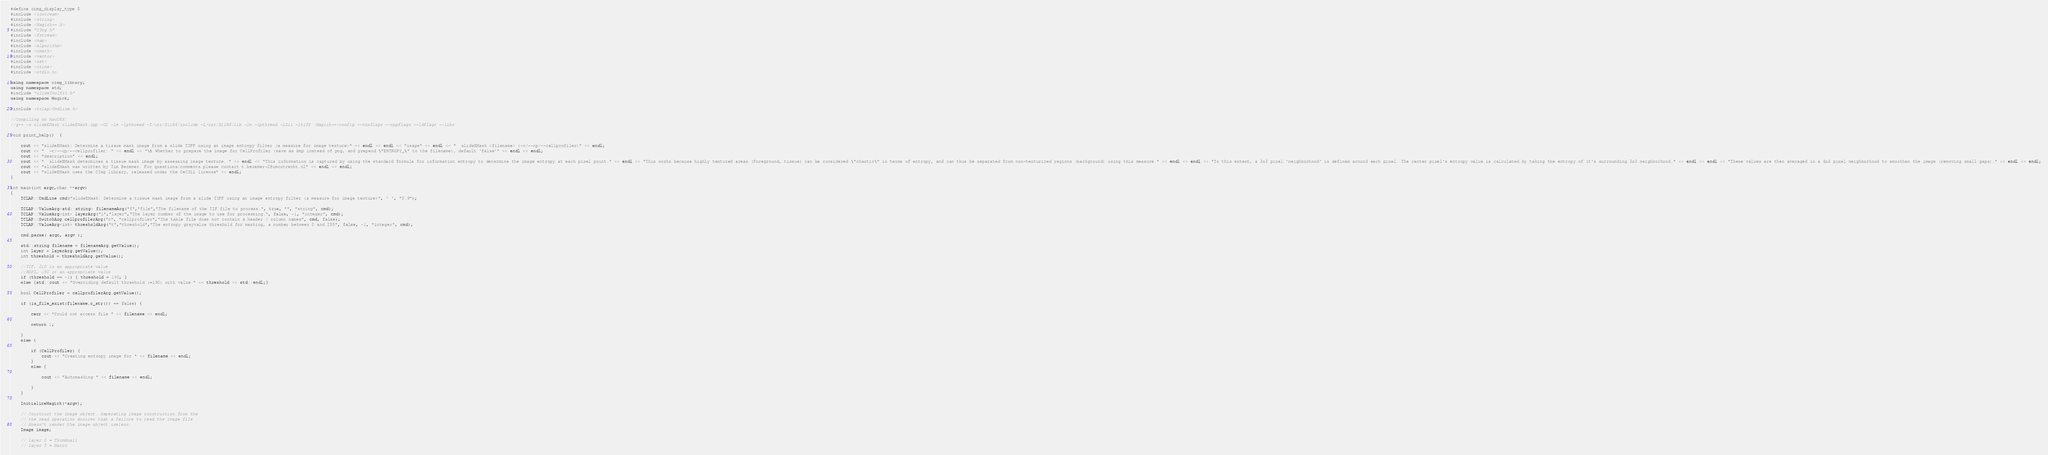<code> <loc_0><loc_0><loc_500><loc_500><_C++_>#define cimg_display_type 0
#include <iostream> 
#include <string>
#include <Magick++.h>
#include "CImg.h"
#include <fstream>
#include <map>
#include <algorithm>
#include <cmath>
#include <vector>
#include <set>
#include <ctime>
#include <stdio.h>

using namespace cimg_library;
using namespace std;
#include "slideToolKit.h"
using namespace Magick;

#include <tclap/CmdLine.h>

//Compiling on MacOSX:
//g++ -o slideEMask slideEMask.cpp -O2 -lm -lpthread -I/usr/X11R6/include -L/usr/X11R6/lib -lm -lpthread -lX11 -ltiff `Magick++-config --cxxflags --cppflags --ldflags --libs`

void print_help()  {

	cout << "slideEMask: Determine a tissue mask image from a slide TIFF using an image entropy filter (a measure for image texture)" << endl << endl << "usage" << endl << "  slideEMask <filename> (-c/--cp/--cellprofiler)" << endl;
	cout << "  -c/--cp/--cellprofiler: " << endl << "\t Whether to prepare the image for CellProfiler (save as bmp instead of png, and prepend \"ENTROPY_\" to the filename), default 'false'" << endl << endl;
	cout << "description" << endl;
	cout << "  slideEMask determines a tissue mask image by assessing image texture. " << endl << "This information is captured by using the standard formula for information entropy to determine the image entropy at each pixel point." << endl << "This works because highly textured areas (foreground, tissue) can be considered \"chaotic\" in terms of entropy, and can thus be separated from non-texturized regions (background) using this measure." << endl << endl << "To this extent, a 3x3 pixel 'neighborhood' is defined around each pixel. The center pixel's entropy value is calculated by taking the entropy of it's surrounding 3x3 neighborhood." << endl << endl << "These values are then averaged in a 4x4 pixel neighborhood to smoothen the image (removing small gaps)." << endl << endl;
	cout << "slideEMask was written by Tim Bezemer. For questions/comments please contact t.bezemer-2@umcutrecht.nl" << endl << endl;
	cout << "slideEMask uses the CImg library, released under the CeCILL license" << endl;
}

int main(int argc,char **argv) 
{ 
	TCLAP::CmdLine cmd("slideEMask: Determine a tissue mask image from a slide TIFF using an image entropy filter (a measure for image texture)", ' ', "0.9");

	TCLAP::ValueArg<std::string> filenameArg("f","file","The filename of the TIF file to process.", true, "", "string", cmd);
	TCLAP::ValueArg<int> layerArg("l","layer","The layer number of the image to use for processing.", false, -1, "integer", cmd);
	TCLAP::SwitchArg cellprofilerArg("c", "cellprofiler","The table file does not contain a header / column names", cmd, false);
	TCLAP::ValueArg<int> thresholdArg("t","threshold","The entropy grayvalue threshold for masking, a number between 0 and 255", false, -1, "integer", cmd);

	cmd.parse( argc, argv );

	std::string filename = filenameArg.getValue();
	int layer = layerArg.getValue();
	int threshold = thresholdArg.getValue();

	//TIF, 210 is an appropriate value
	//NDPI, 190 is an appropriate value
	if (threshold == -1) { threshold = 190; }
	else {std::cout << "Overriding default threshold (=190) with value " << threshold << std::endl;}

	bool CellProfiler = cellprofilerArg.getValue();

	if (is_file_exist(filename.c_str()) == false) {

		cerr << "Could not access file " << filename << endl;

        return 1;

	}
	else {

		if (CellProfiler) {
			cout << "Creating entropy image for " << filename << endl;
		}
		else {

			cout << "Automasking " << filename << endl;

		}
	}

	InitializeMagick(*argv);

    // Construct the image object. Seperating image construction from the 
    // the read operation ensures that a failure to read the image file 
    // doesn't render the image object useless. 
    Image image;

    // layer 0 = Thumbnail
    // layer 5 = Macro</code> 